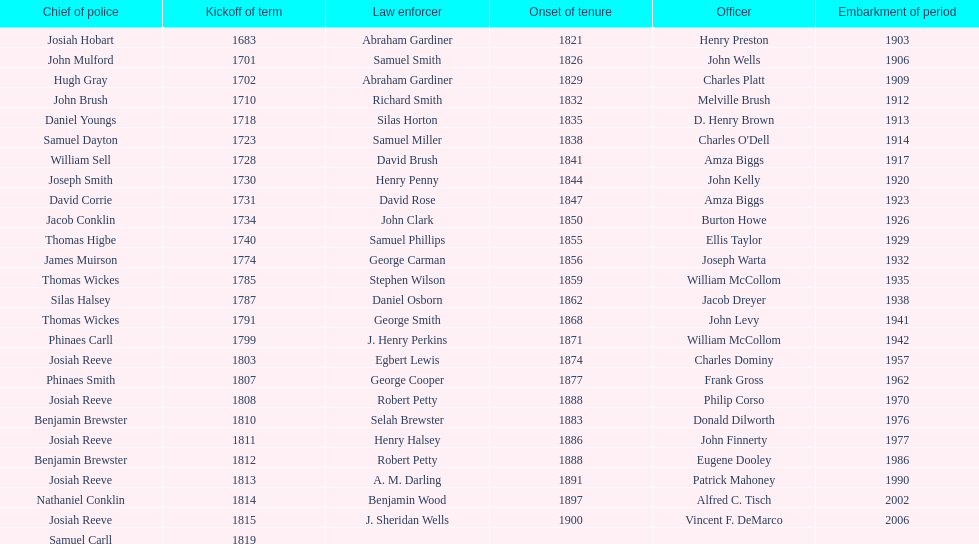How sheriffs has suffolk county had in total? 76. 